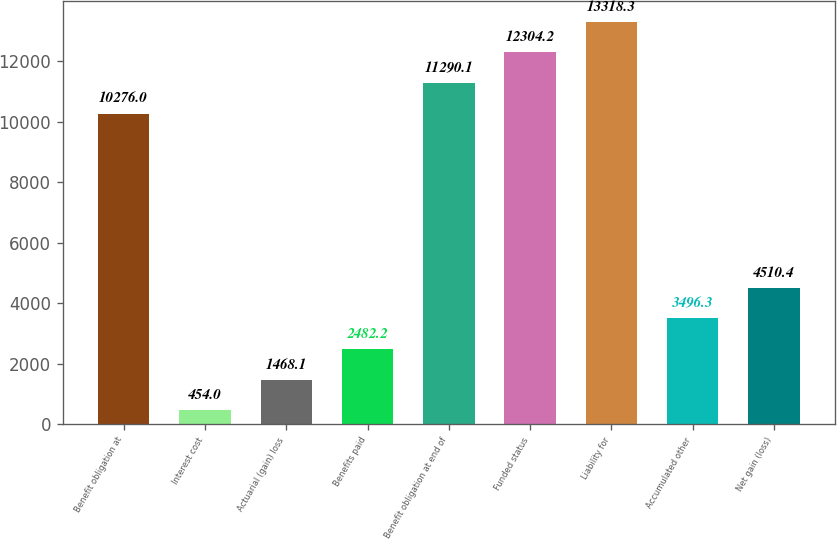<chart> <loc_0><loc_0><loc_500><loc_500><bar_chart><fcel>Benefit obligation at<fcel>Interest cost<fcel>Actuarial (gain) loss<fcel>Benefits paid<fcel>Benefit obligation at end of<fcel>Funded status<fcel>Liability for<fcel>Accumulated other<fcel>Net gain (loss)<nl><fcel>10276<fcel>454<fcel>1468.1<fcel>2482.2<fcel>11290.1<fcel>12304.2<fcel>13318.3<fcel>3496.3<fcel>4510.4<nl></chart> 